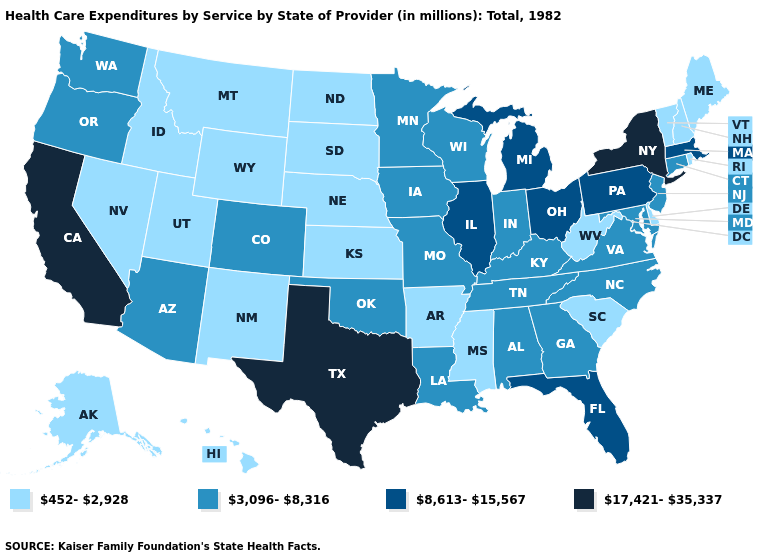Name the states that have a value in the range 452-2,928?
Short answer required. Alaska, Arkansas, Delaware, Hawaii, Idaho, Kansas, Maine, Mississippi, Montana, Nebraska, Nevada, New Hampshire, New Mexico, North Dakota, Rhode Island, South Carolina, South Dakota, Utah, Vermont, West Virginia, Wyoming. Does the map have missing data?
Write a very short answer. No. Which states hav the highest value in the MidWest?
Be succinct. Illinois, Michigan, Ohio. Name the states that have a value in the range 8,613-15,567?
Answer briefly. Florida, Illinois, Massachusetts, Michigan, Ohio, Pennsylvania. Does Wyoming have the lowest value in the West?
Short answer required. Yes. Does the map have missing data?
Give a very brief answer. No. Among the states that border Utah , does Idaho have the lowest value?
Short answer required. Yes. Does Pennsylvania have the same value as Alaska?
Short answer required. No. Which states hav the highest value in the Northeast?
Short answer required. New York. What is the value of Massachusetts?
Short answer required. 8,613-15,567. What is the highest value in states that border Kansas?
Answer briefly. 3,096-8,316. Does the first symbol in the legend represent the smallest category?
Short answer required. Yes. What is the lowest value in the South?
Quick response, please. 452-2,928. Which states have the highest value in the USA?
Concise answer only. California, New York, Texas. Which states have the lowest value in the USA?
Keep it brief. Alaska, Arkansas, Delaware, Hawaii, Idaho, Kansas, Maine, Mississippi, Montana, Nebraska, Nevada, New Hampshire, New Mexico, North Dakota, Rhode Island, South Carolina, South Dakota, Utah, Vermont, West Virginia, Wyoming. 